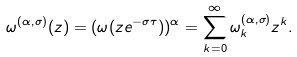<formula> <loc_0><loc_0><loc_500><loc_500>\omega ^ { ( \alpha , \sigma ) } ( z ) = ( \omega ( z e ^ { - \sigma \tau } ) ) ^ { \alpha } = \sum _ { k = 0 } ^ { \infty } \omega ^ { ( \alpha , \sigma ) } _ { k } z ^ { k } .</formula> 